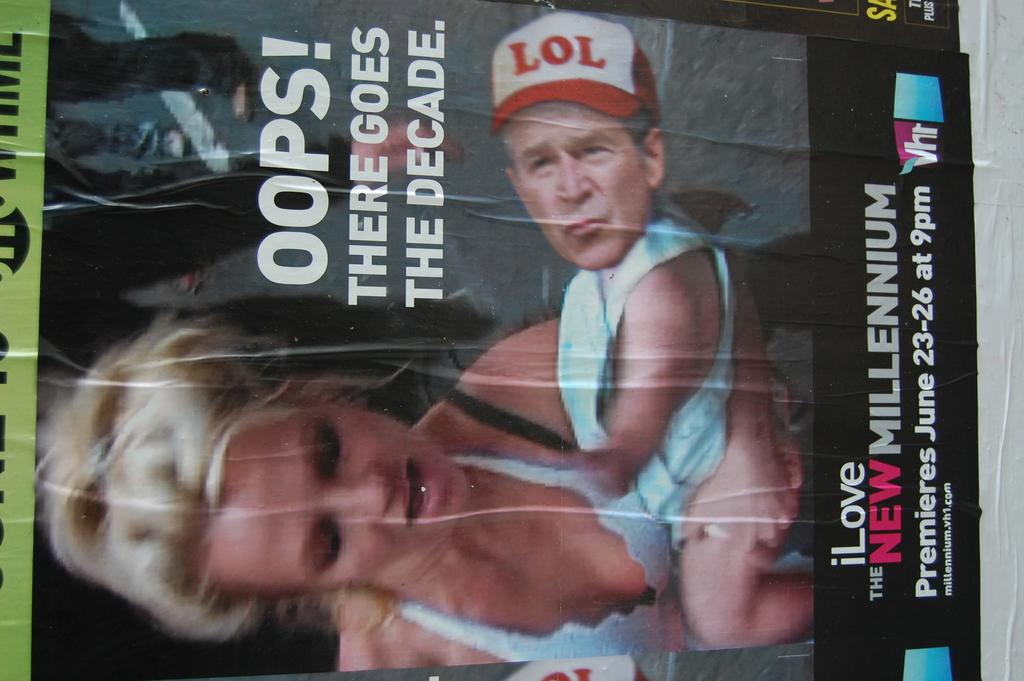What is the main object in the image? There is a magazine in the image. Can you describe the magazine in the image? The magazine appears to be a printed publication with pages and a cover. What type of trees can be seen in the background of the image? There is no background or trees present in the image; it only features a magazine. 